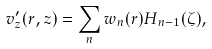Convert formula to latex. <formula><loc_0><loc_0><loc_500><loc_500>v _ { z } ^ { \prime } ( r , z ) = \sum _ { n } w _ { n } ( r ) H _ { n - 1 } ( \zeta ) ,</formula> 